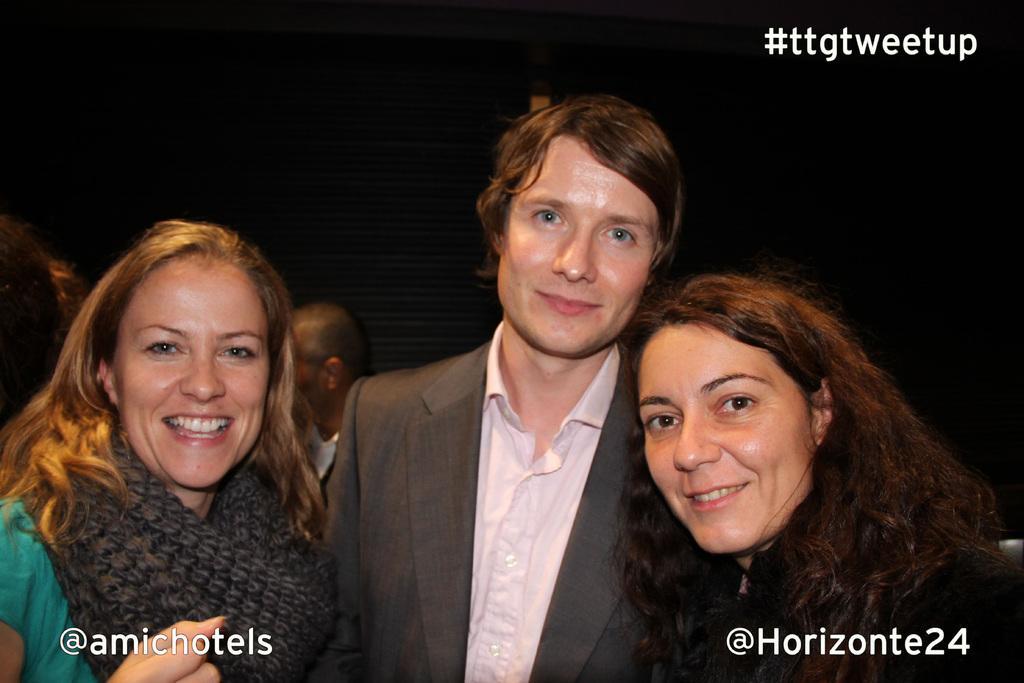How would you summarize this image in a sentence or two? In this image, we can see three persons are watching and smiling. Background we can see people, black color object and dark view. 